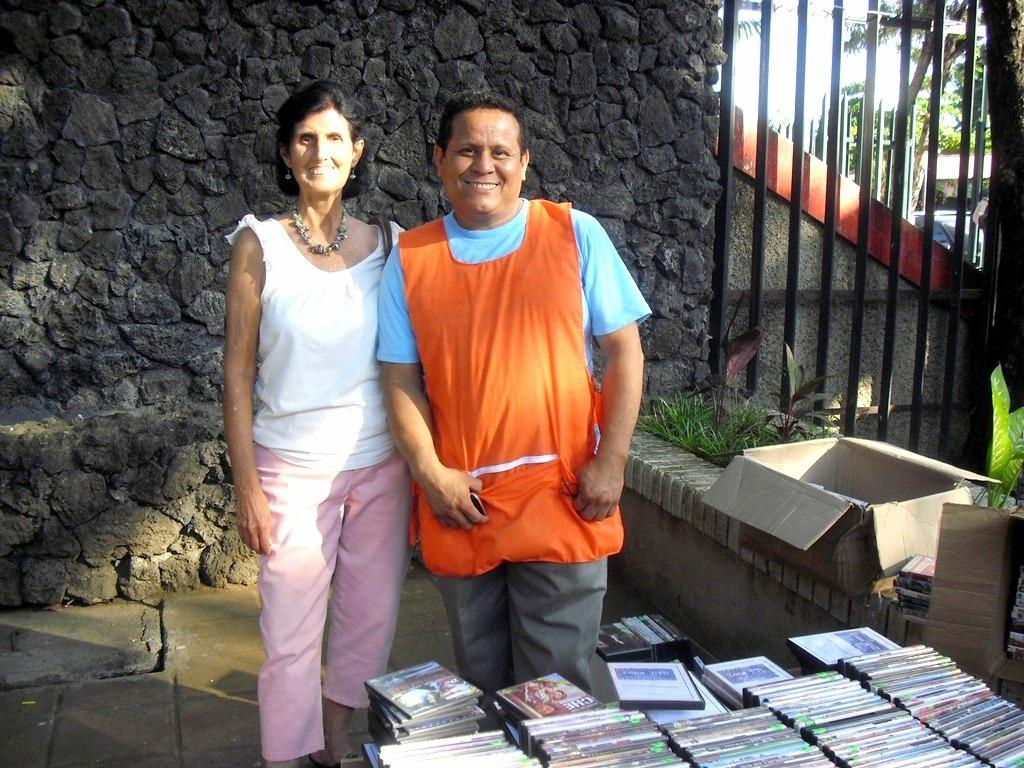Who are the people in the image? There is a man and a woman in the image. Where are they standing? They are standing on a path. What items can be seen in the image besides the people? Books and boxes on the wall are visible in the image. What can be seen in the background of the image? Trees are present in the background of the image. How many pears are on the ground in the image? There are no pears present in the image. What type of snakes are crawling on the path in the image? There are no snakes present in the image. 